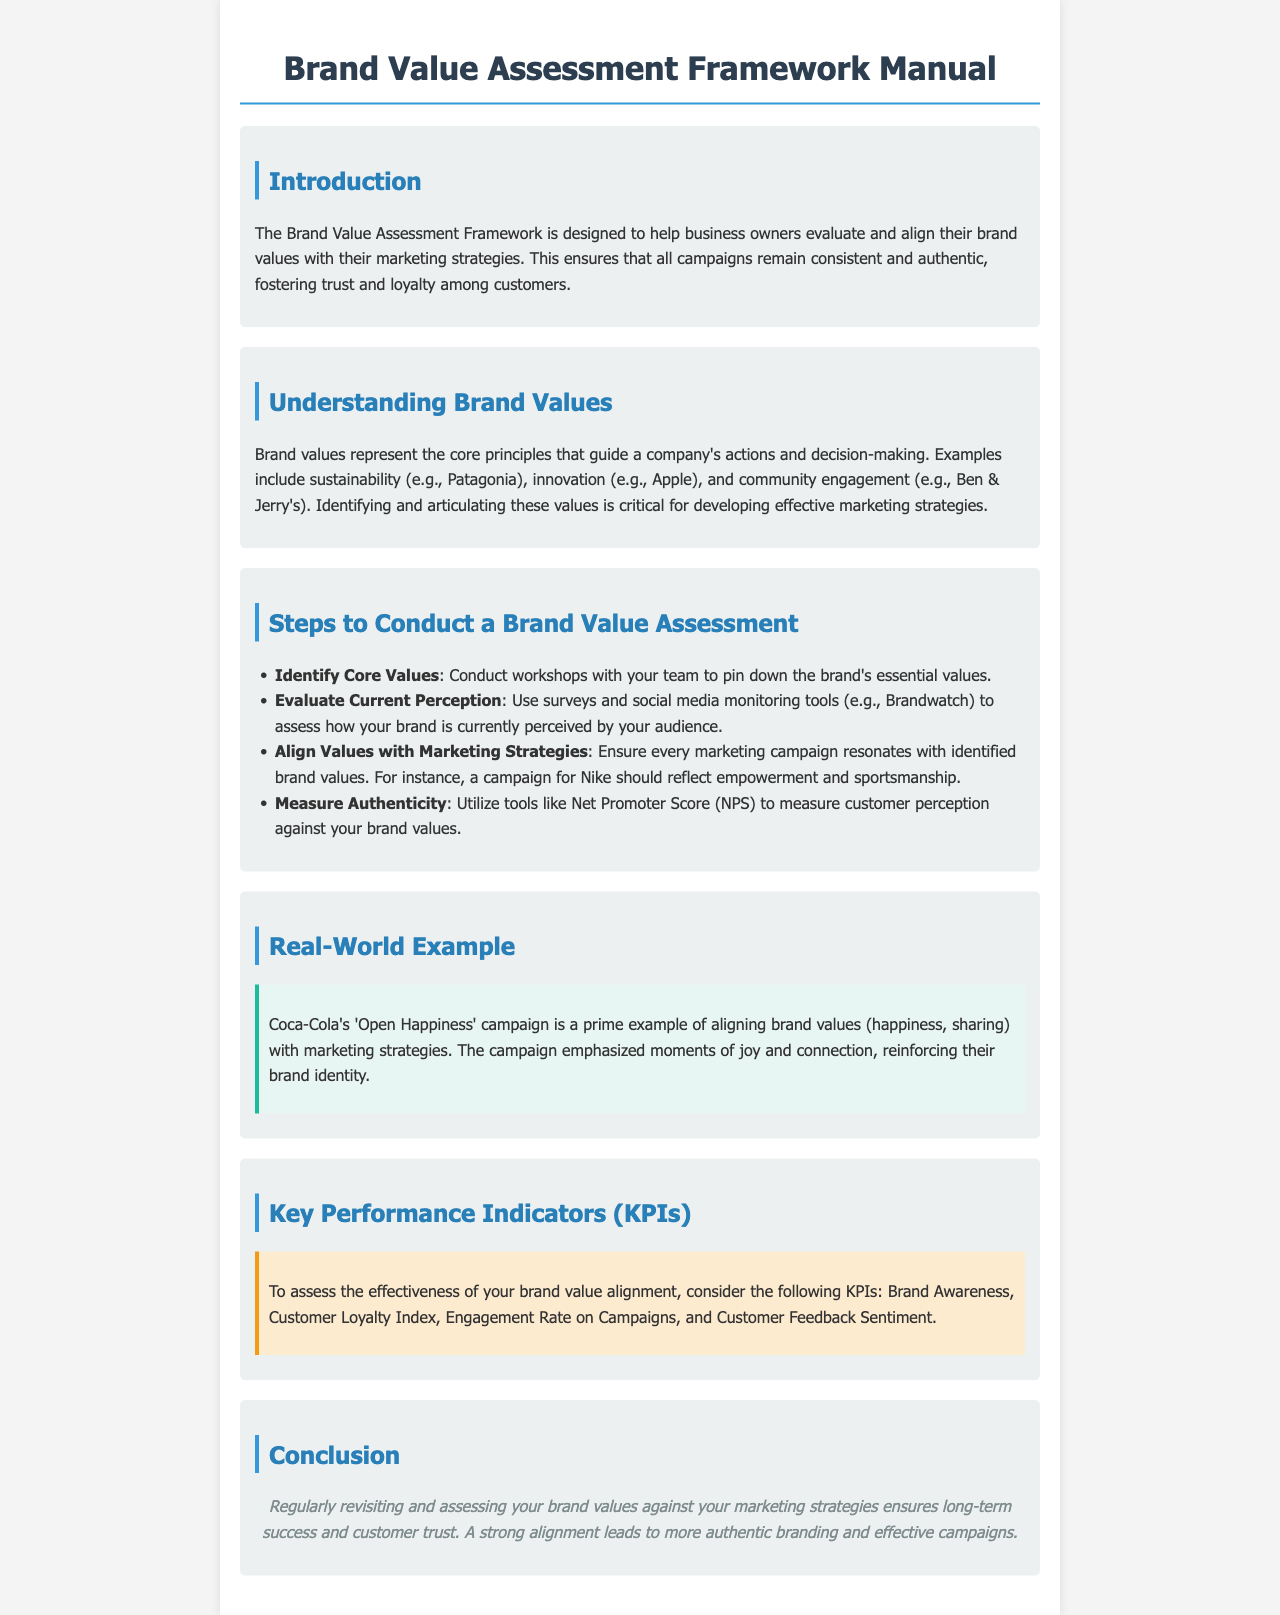What is the purpose of the Brand Value Assessment Framework? The purpose is to help business owners evaluate and align their brand values with marketing strategies to ensure consistency and authenticity in campaigns.
Answer: Evaluate and align brand values What are brand values? Brand values are the core principles that guide a company's actions and decision-making, such as sustainability or innovation.
Answer: Core principles What is the first step to conduct a Brand Value Assessment? The first step is to conduct workshops with your team to identify the brand's essential values.
Answer: Identify Core Values What real-world example is provided in the document? The document provides Coca-Cola's 'Open Happiness' campaign as an example of aligning brand values with marketing strategies.
Answer: Coca-Cola's 'Open Happiness' campaign Which tool is suggested to measure authenticity? The document suggests utilizing the Net Promoter Score (NPS) to measure customer perception against brand values.
Answer: Net Promoter Score (NPS) How many KPIs are listed in the document? The document mentions four Key Performance Indicators (KPIs) to assess brand value alignment.
Answer: Four What is emphasized in the conclusion of the document? The conclusion emphasizes that regularly assessing brand values against marketing strategies ensures long-term success and customer trust.
Answer: Long-term success and customer trust What is an example of a brand value mentioned in the document? The document mentions sustainability, innovation, and community engagement as examples of brand values.
Answer: Sustainability What does the example given in the document illustrate? The example illustrates how Coca-Cola's campaign aligns its brand values with its marketing strategy.
Answer: Aligning brand values with marketing strategy 